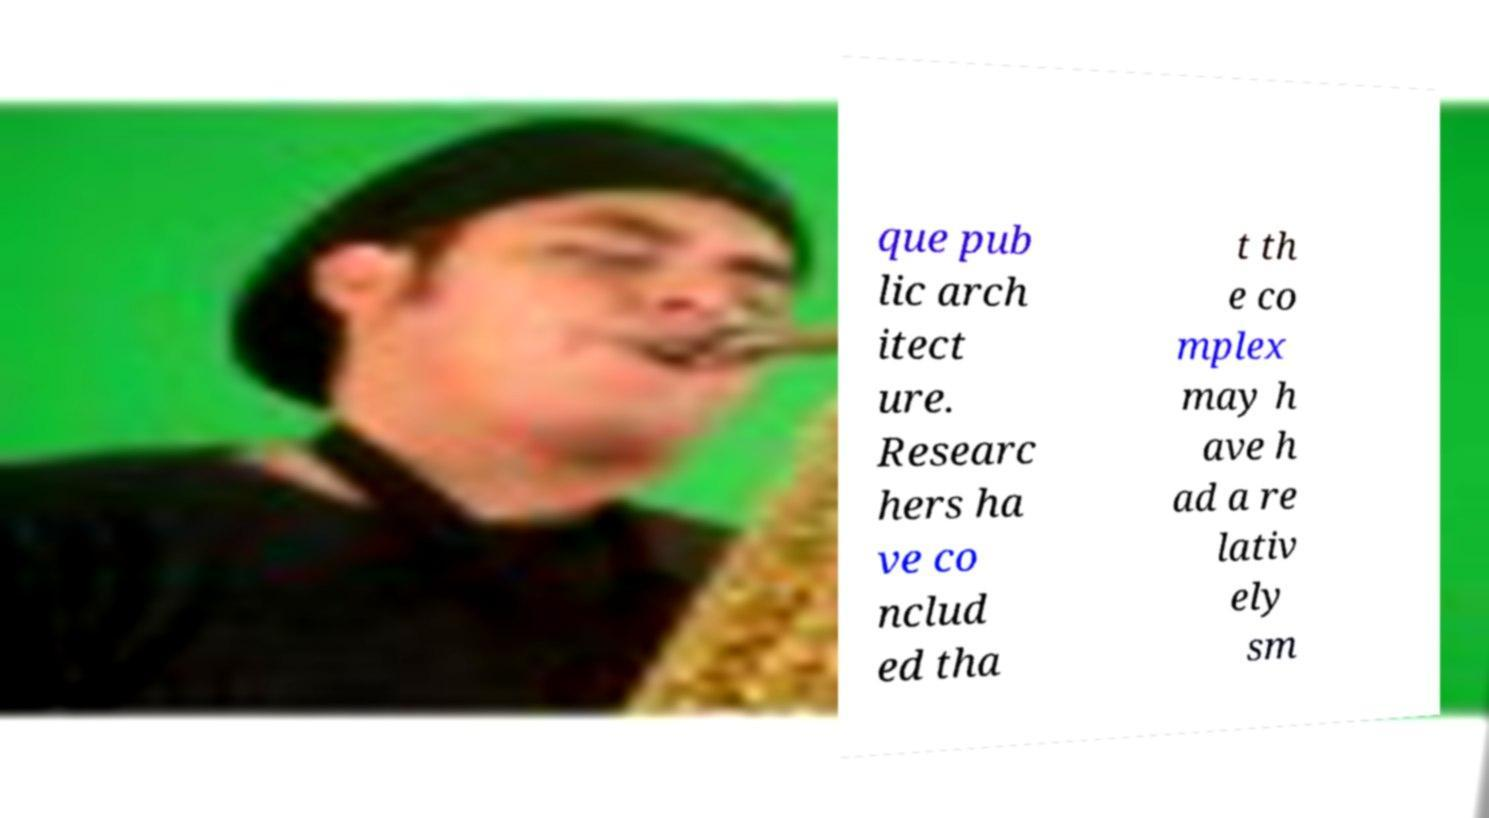Please read and relay the text visible in this image. What does it say? que pub lic arch itect ure. Researc hers ha ve co nclud ed tha t th e co mplex may h ave h ad a re lativ ely sm 